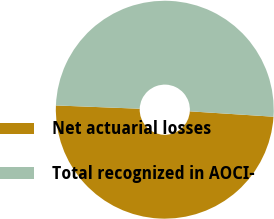Convert chart. <chart><loc_0><loc_0><loc_500><loc_500><pie_chart><fcel>Net actuarial losses<fcel>Total recognized in AOCI-<nl><fcel>49.6%<fcel>50.4%<nl></chart> 